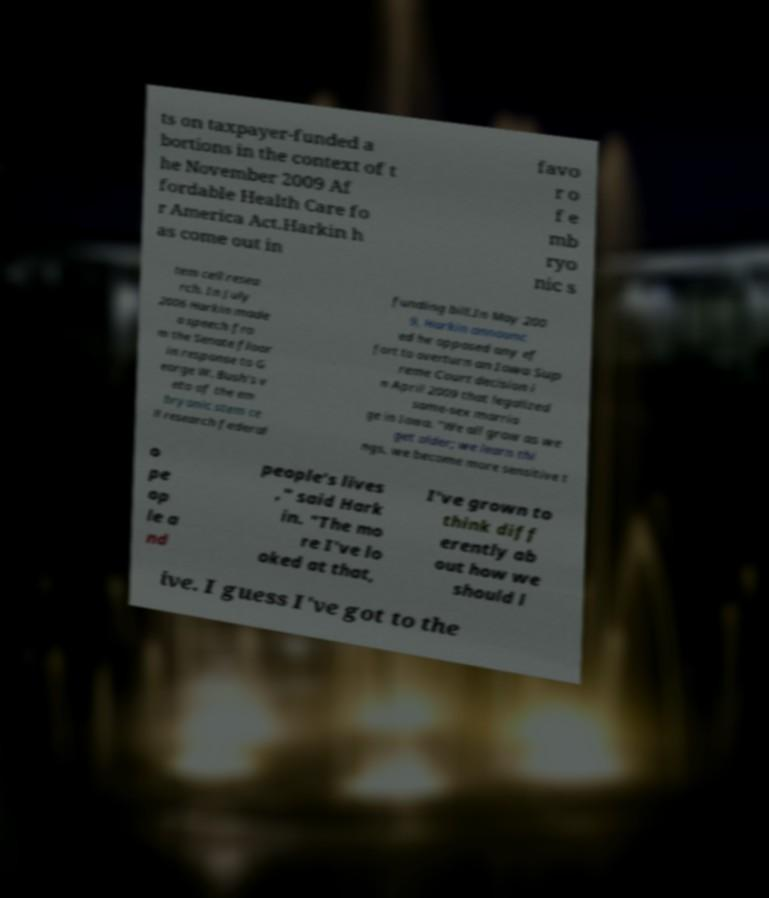There's text embedded in this image that I need extracted. Can you transcribe it verbatim? ts on taxpayer-funded a bortions in the context of t he November 2009 Af fordable Health Care fo r America Act.Harkin h as come out in favo r o f e mb ryo nic s tem cell resea rch. In July 2006 Harkin made a speech fro m the Senate floor in response to G eorge W. Bush's v eto of the em bryonic stem ce ll research federal funding bill.In May 200 9, Harkin announc ed he opposed any ef fort to overturn an Iowa Sup reme Court decision i n April 2009 that legalized same-sex marria ge in Iowa. "We all grow as we get older; we learn thi ngs, we become more sensitive t o pe op le a nd people's lives ," said Hark in. "The mo re I've lo oked at that, I've grown to think diff erently ab out how we should l ive. I guess I've got to the 